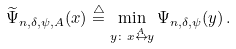<formula> <loc_0><loc_0><loc_500><loc_500>\widetilde { \Psi } _ { n , \delta , \psi , A } ( x ) \overset { \triangle } { = } \min _ { y \colon x \overset { A } { \leftrightarrow } y } \Psi _ { n , \delta , \psi } ( y ) \, .</formula> 